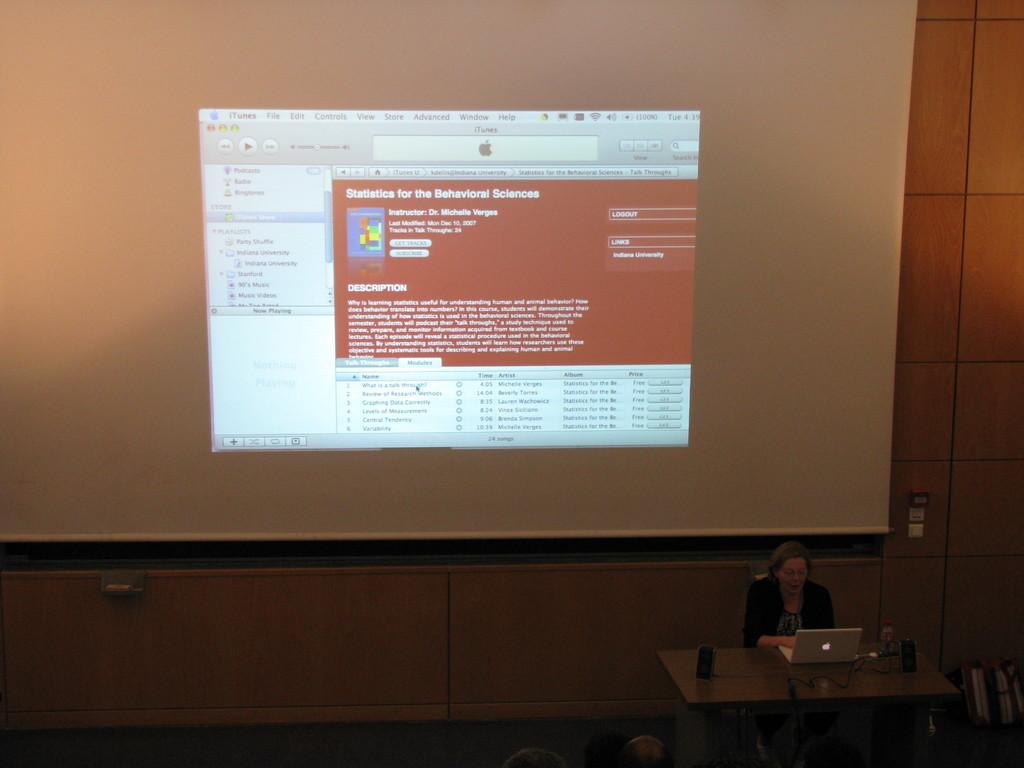<image>
Render a clear and concise summary of the photo. a screen with a webpage about statistics for the behavioral sciences 